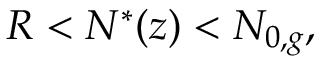<formula> <loc_0><loc_0><loc_500><loc_500>R < N ^ { * } ( z ) < N _ { 0 , g } ,</formula> 